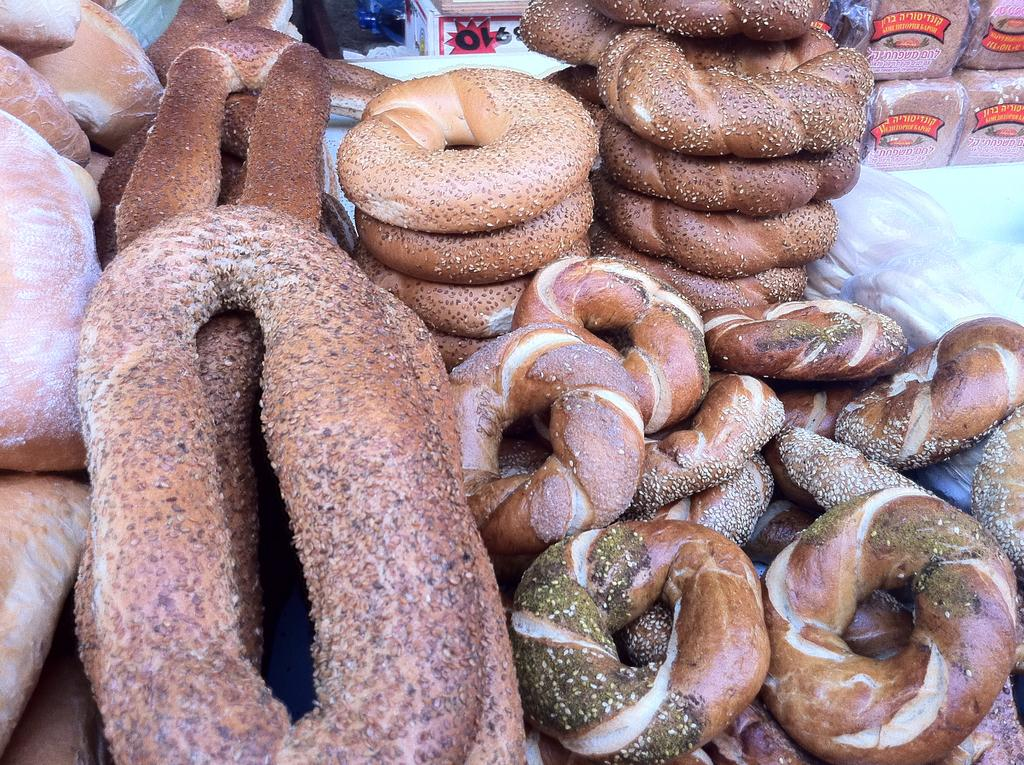What is the main subject in the foreground of the image? There are many donuts on a table in the foreground of the image. What can be seen in the background of the image? In the background, there is a table visible. What type of food items are present in the background of the image? Bread packets are present in the background of the image. What type of curtain can be seen hanging from the ceiling in the image? There is no curtain present in the image. How is the quilt used in the image? There is no quilt present in the image. 